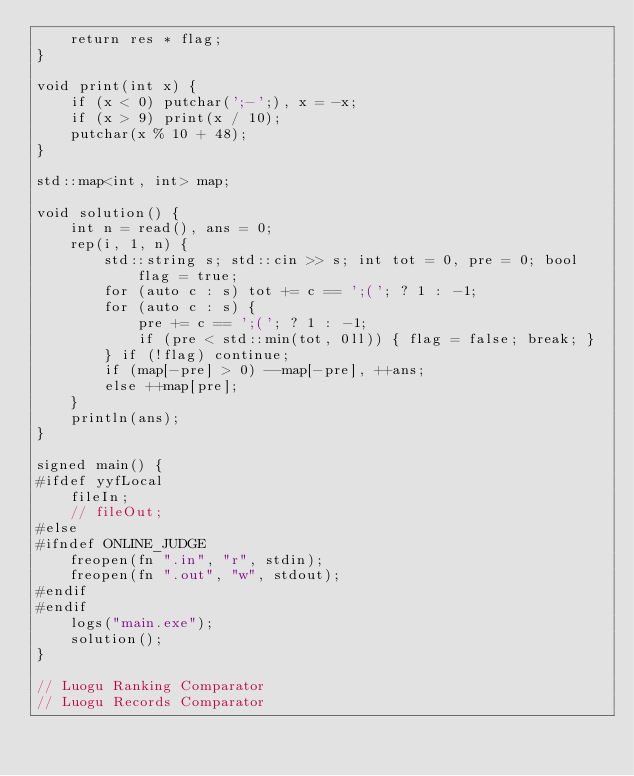Convert code to text. <code><loc_0><loc_0><loc_500><loc_500><_C++_>    return res * flag;
}

void print(int x) {
    if (x < 0) putchar(';-';), x = -x;
    if (x > 9) print(x / 10);
    putchar(x % 10 + 48);
}

std::map<int, int> map;

void solution() {
    int n = read(), ans = 0; 
    rep(i, 1, n) {
        std::string s; std::cin >> s; int tot = 0, pre = 0; bool flag = true;
        for (auto c : s) tot += c == ';('; ? 1 : -1;
        for (auto c : s) {
            pre += c == ';('; ? 1 : -1;
            if (pre < std::min(tot, 0ll)) { flag = false; break; }
        } if (!flag) continue;
        if (map[-pre] > 0) --map[-pre], ++ans;
        else ++map[pre];
    }
    println(ans);
}

signed main() {
#ifdef yyfLocal
    fileIn;
    // fileOut;
#else  
#ifndef ONLINE_JUDGE   
    freopen(fn ".in", "r", stdin);
    freopen(fn ".out", "w", stdout);
#endif
#endif
    logs("main.exe");
    solution();
}

// Luogu Ranking Comparator
// Luogu Records Comparator
</code> 